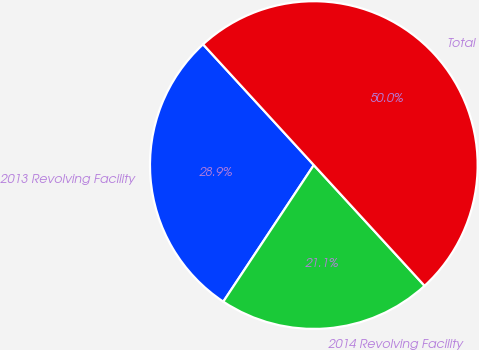<chart> <loc_0><loc_0><loc_500><loc_500><pie_chart><fcel>2013 Revolving Facility<fcel>2014 Revolving Facility<fcel>Total<nl><fcel>28.87%<fcel>21.13%<fcel>50.0%<nl></chart> 